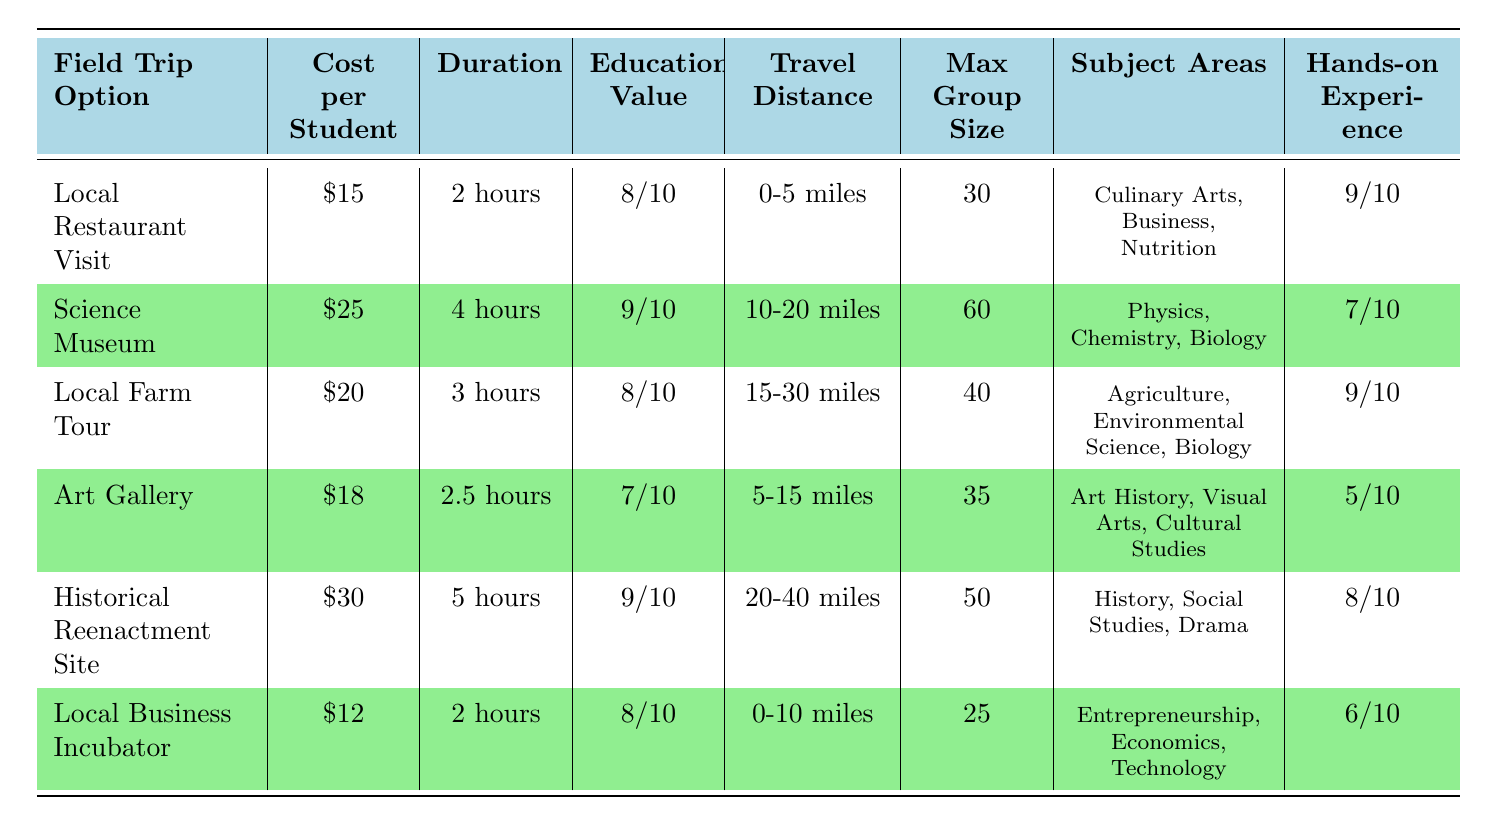What is the cost per student for the Local Farm Tour? The table lists the Local Farm Tour option under the "Field Trip Option" column, where the "Cost per Student" column indicates the cost. This amount is $20.
Answer: 20 What is the maximum group size for the Science Museum trip? The table shows that the Science Museum has a maximum group size listed in the "Max Group Size" column, which is 60.
Answer: 60 Which field trip option offers the highest educational value? By comparing the "Educational Value" column, both the Science Museum and the Historical Reenactment Site have an educational value of 9/10, higher than any other options.
Answer: Science Museum and Historical Reenactment Site What is the total cost for a full group of 30 students going to the Local Restaurant Visit? The cost per student for the Local Restaurant Visit is $15. To find the total cost, we multiply this by the group size (30): 15 * 30 = 450.
Answer: 450 Is the Local Business Incubator trip cheaper than the Art Gallery trip? The "Cost per Student" for the Local Business Incubator is $12, while for the Art Gallery, it is $18. Since $12 is less than $18, the statement is true.
Answer: Yes Which field trip option has the longest duration? The "Duration" column indicates that the Historical Reenactment Site has the longest duration of 5 hours, as it's longer than all other trip durations listed.
Answer: Historical Reenactment Site What is the average cost per student for all field trip options? First, we add the costs: 15 + 25 + 20 + 18 + 30 + 12 = 130. There are 6 options, so we divide the total by 6: 130 / 6 = approximately 21.67.
Answer: 21.67 Which field trip options have a hands-on experience rating of 9? The table shows that both the Local Restaurant Visit and the Local Farm Tour have a hands-on experience rating of 9/10.
Answer: Local Restaurant Visit and Local Farm Tour Is the travel distance for the Art Gallery less than that of the Science Museum? The travel distance for the Art Gallery is 5-15 miles, while for the Science Museum, it is 10-20 miles. Since 5-15 miles has lower minimum and maximum values compared to 10-20 miles, the statement is true.
Answer: Yes 